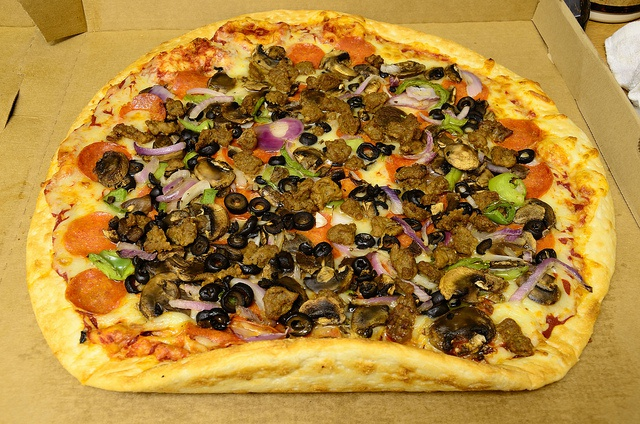Describe the objects in this image and their specific colors. I can see a pizza in tan, olive, black, gold, and orange tones in this image. 